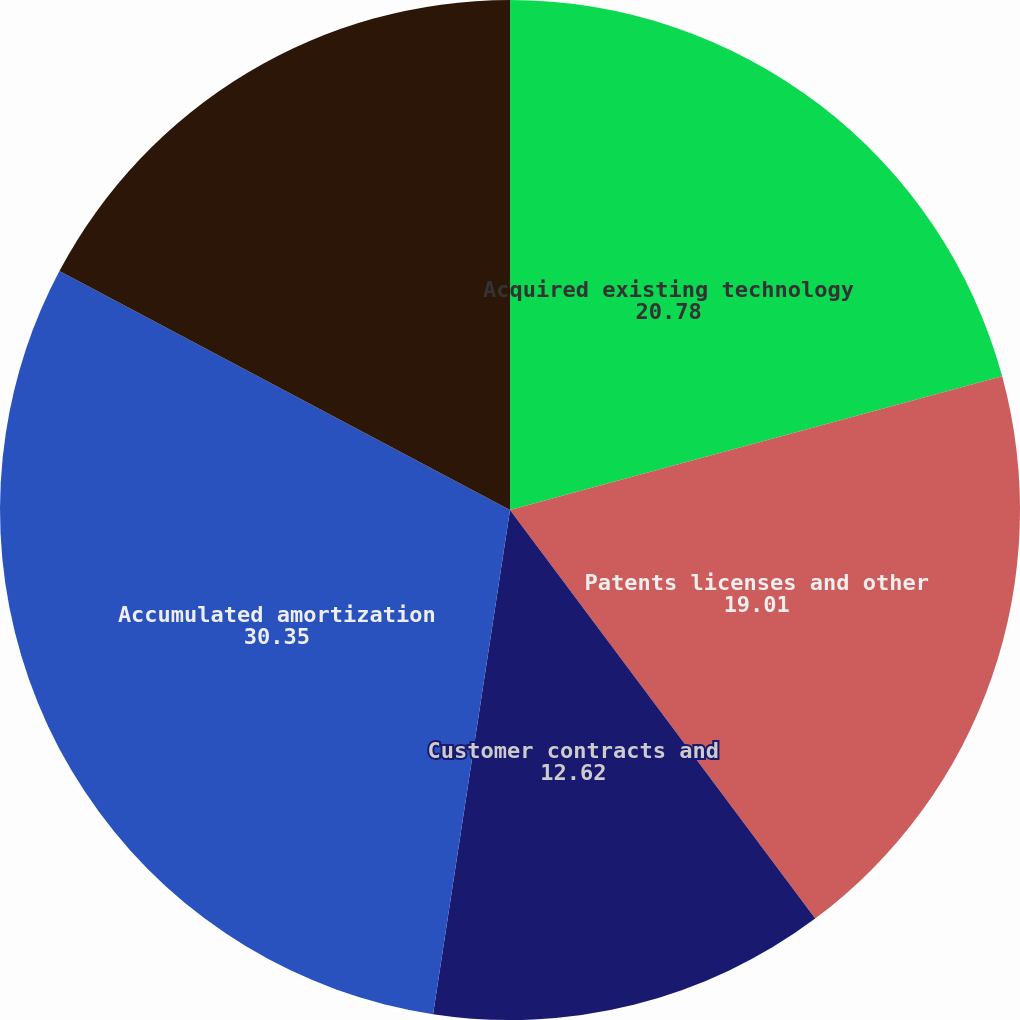Convert chart to OTSL. <chart><loc_0><loc_0><loc_500><loc_500><pie_chart><fcel>Acquired existing technology<fcel>Patents licenses and other<fcel>Customer contracts and<fcel>Accumulated amortization<fcel>Net carrying amount<nl><fcel>20.78%<fcel>19.01%<fcel>12.62%<fcel>30.35%<fcel>17.24%<nl></chart> 